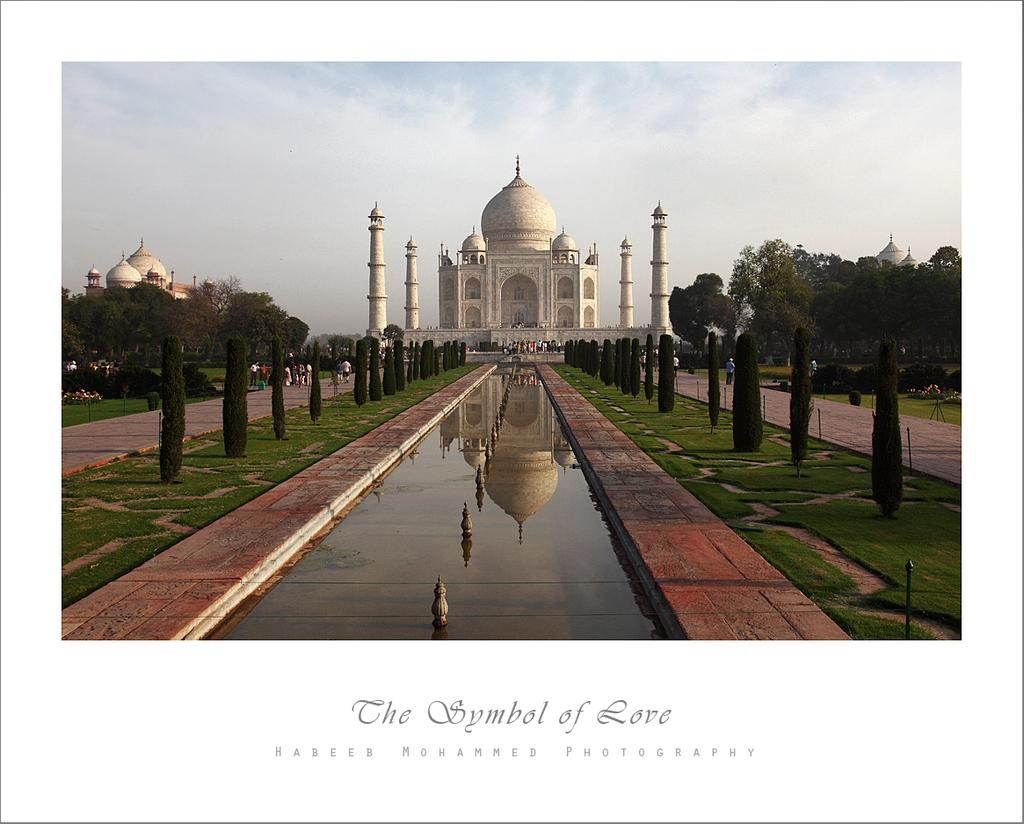What is the weather like in the image? The sky is cloudy in the image. What type of natural environment is visible in the image? There is water, grass, trees, and plants visible in the image. What can be seen in the distance in the image? People and buildings are visible in the distance. What type of hat is being pulled out of the sink in the image? There is no hat or sink present in the image. 